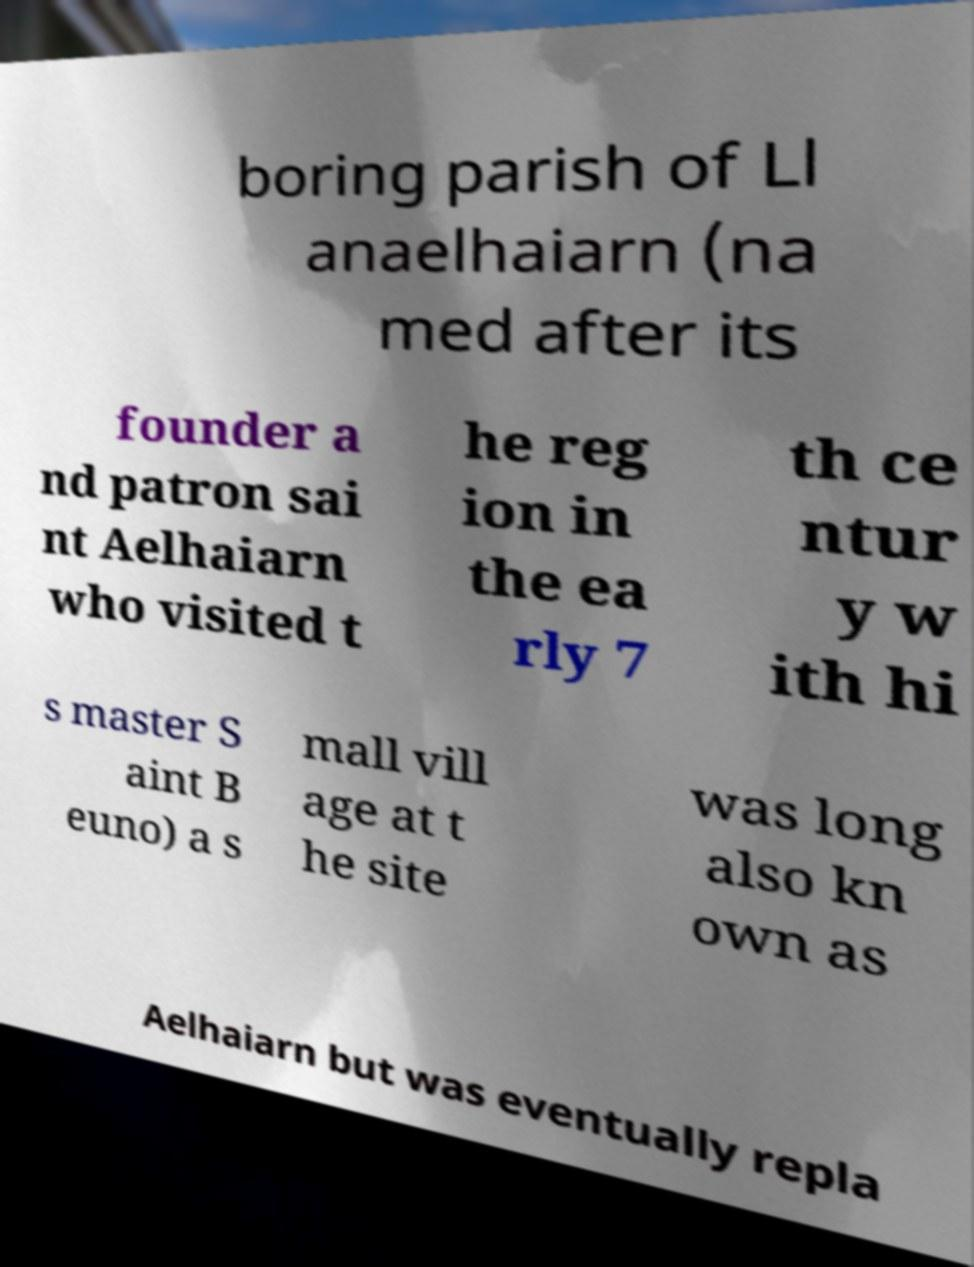Could you extract and type out the text from this image? boring parish of Ll anaelhaiarn (na med after its founder a nd patron sai nt Aelhaiarn who visited t he reg ion in the ea rly 7 th ce ntur y w ith hi s master S aint B euno) a s mall vill age at t he site was long also kn own as Aelhaiarn but was eventually repla 